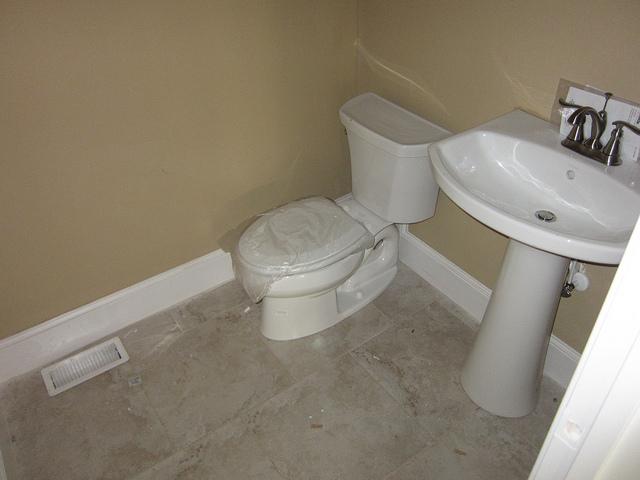What is the grate in the floor?
Quick response, please. Vent. Is the wall made of wood?
Short answer required. No. Do these items need replaced?
Concise answer only. No. What is on the toilet seat?
Quick response, please. Plastic. How many toilets are pictured?
Write a very short answer. 1. Do both the toilet seat and sink basin have plastic wrap on them?
Be succinct. No. Is the toilet seat broken?
Answer briefly. No. 